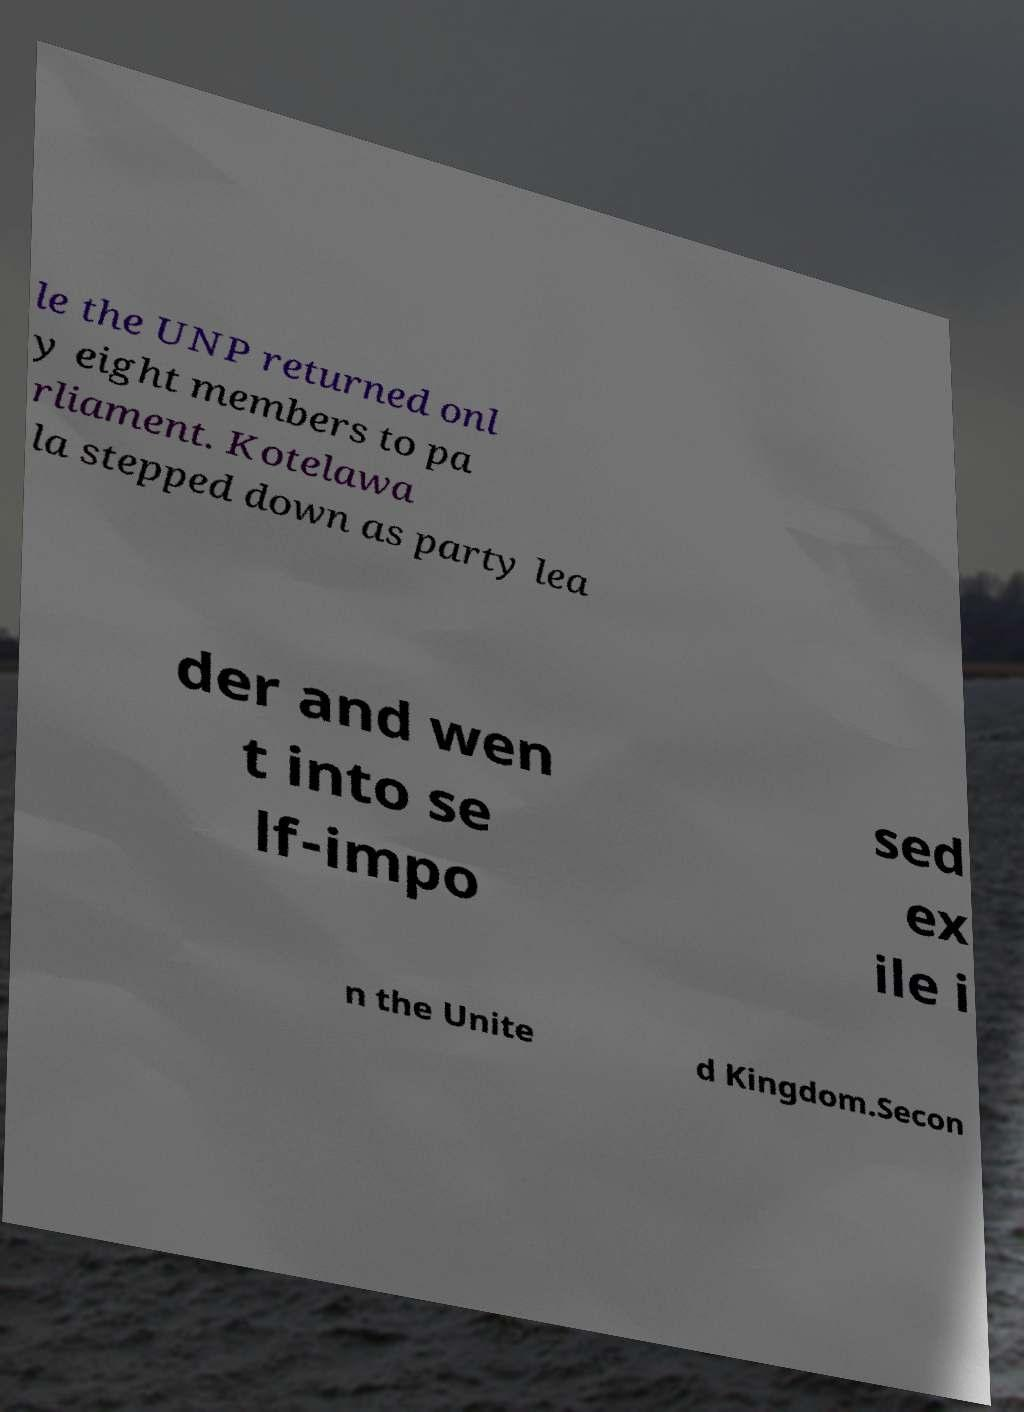What messages or text are displayed in this image? I need them in a readable, typed format. le the UNP returned onl y eight members to pa rliament. Kotelawa la stepped down as party lea der and wen t into se lf-impo sed ex ile i n the Unite d Kingdom.Secon 